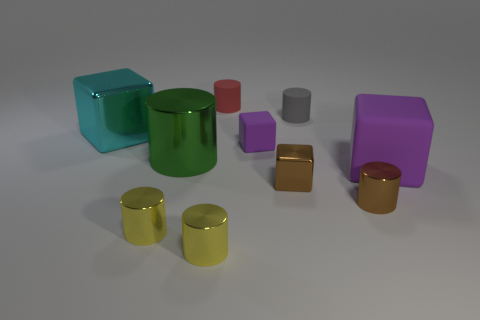The gray cylinder is what size?
Provide a short and direct response. Small. What shape is the tiny purple thing that is made of the same material as the large purple block?
Provide a short and direct response. Cube. Does the big object that is right of the red rubber cylinder have the same shape as the small red thing?
Offer a very short reply. No. How many objects are either yellow metallic things or small gray objects?
Your response must be concise. 3. The tiny cylinder that is both on the left side of the tiny brown shiny cylinder and right of the brown cube is made of what material?
Offer a terse response. Rubber. Is the size of the cyan metal cube the same as the brown metallic block?
Give a very brief answer. No. What size is the cube to the left of the cylinder to the left of the large green shiny cylinder?
Ensure brevity in your answer.  Large. How many small objects are both behind the tiny gray cylinder and in front of the big cyan metal cube?
Provide a succinct answer. 0. There is a shiny block to the right of the large cyan cube in front of the tiny gray matte cylinder; is there a large cyan cube that is in front of it?
Ensure brevity in your answer.  No. What shape is the purple rubber thing that is the same size as the cyan object?
Your answer should be compact. Cube. 